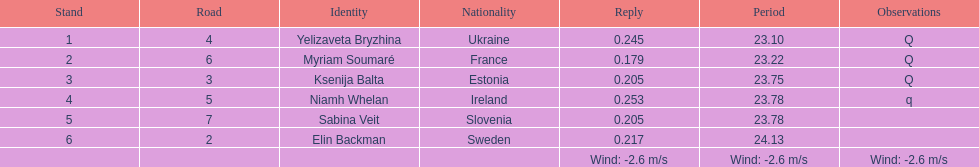Whose time is more than. 24.00? Elin Backman. 